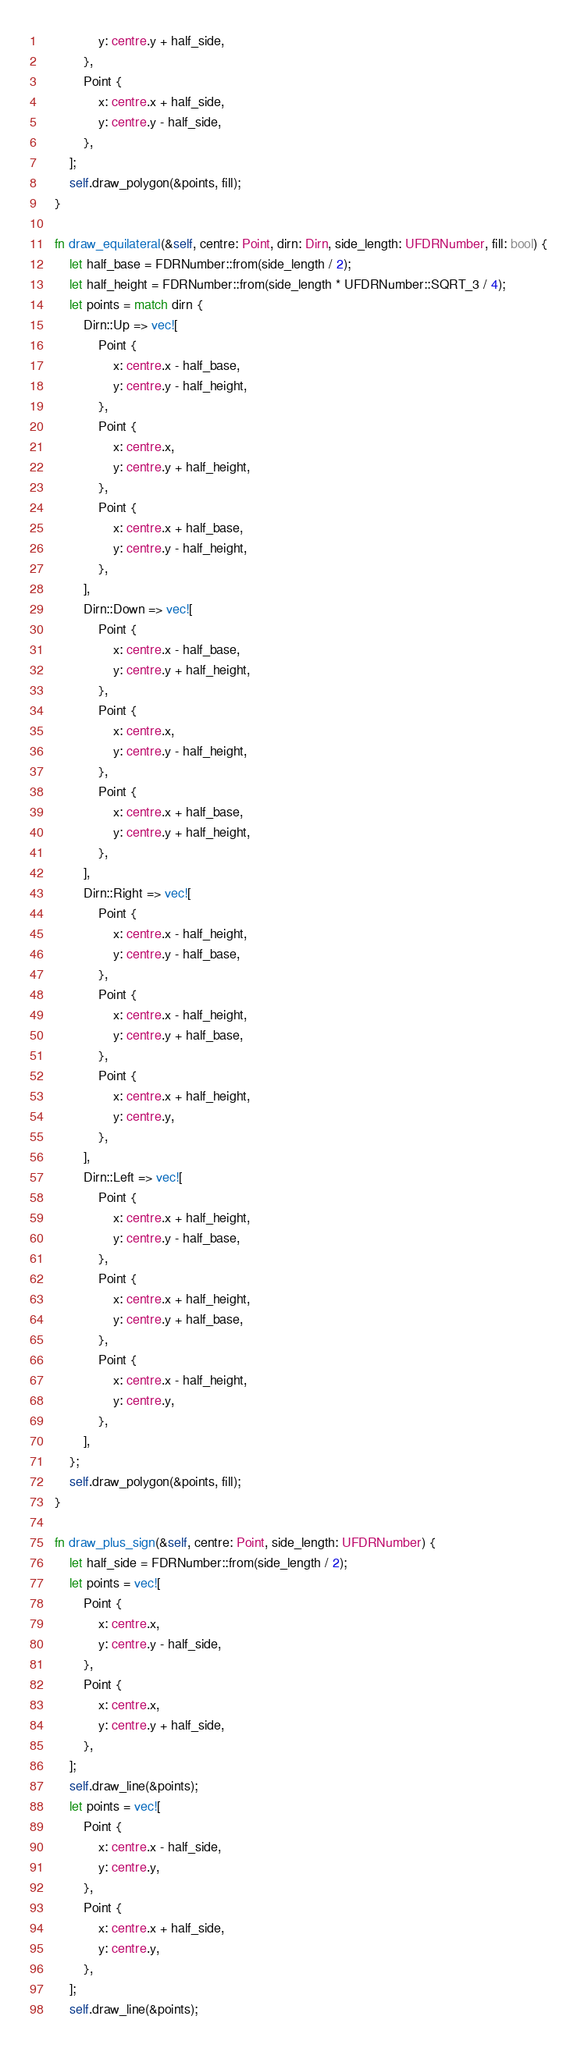Convert code to text. <code><loc_0><loc_0><loc_500><loc_500><_Rust_>                y: centre.y + half_side,
            },
            Point {
                x: centre.x + half_side,
                y: centre.y - half_side,
            },
        ];
        self.draw_polygon(&points, fill);
    }

    fn draw_equilateral(&self, centre: Point, dirn: Dirn, side_length: UFDRNumber, fill: bool) {
        let half_base = FDRNumber::from(side_length / 2);
        let half_height = FDRNumber::from(side_length * UFDRNumber::SQRT_3 / 4);
        let points = match dirn {
            Dirn::Up => vec![
                Point {
                    x: centre.x - half_base,
                    y: centre.y - half_height,
                },
                Point {
                    x: centre.x,
                    y: centre.y + half_height,
                },
                Point {
                    x: centre.x + half_base,
                    y: centre.y - half_height,
                },
            ],
            Dirn::Down => vec![
                Point {
                    x: centre.x - half_base,
                    y: centre.y + half_height,
                },
                Point {
                    x: centre.x,
                    y: centre.y - half_height,
                },
                Point {
                    x: centre.x + half_base,
                    y: centre.y + half_height,
                },
            ],
            Dirn::Right => vec![
                Point {
                    x: centre.x - half_height,
                    y: centre.y - half_base,
                },
                Point {
                    x: centre.x - half_height,
                    y: centre.y + half_base,
                },
                Point {
                    x: centre.x + half_height,
                    y: centre.y,
                },
            ],
            Dirn::Left => vec![
                Point {
                    x: centre.x + half_height,
                    y: centre.y - half_base,
                },
                Point {
                    x: centre.x + half_height,
                    y: centre.y + half_base,
                },
                Point {
                    x: centre.x - half_height,
                    y: centre.y,
                },
            ],
        };
        self.draw_polygon(&points, fill);
    }

    fn draw_plus_sign(&self, centre: Point, side_length: UFDRNumber) {
        let half_side = FDRNumber::from(side_length / 2);
        let points = vec![
            Point {
                x: centre.x,
                y: centre.y - half_side,
            },
            Point {
                x: centre.x,
                y: centre.y + half_side,
            },
        ];
        self.draw_line(&points);
        let points = vec![
            Point {
                x: centre.x - half_side,
                y: centre.y,
            },
            Point {
                x: centre.x + half_side,
                y: centre.y,
            },
        ];
        self.draw_line(&points);</code> 